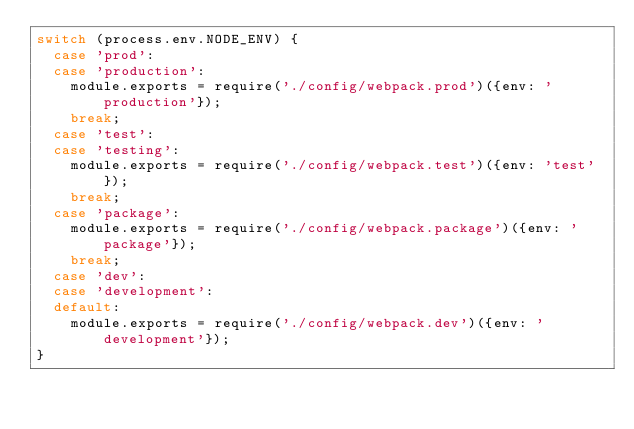<code> <loc_0><loc_0><loc_500><loc_500><_JavaScript_>switch (process.env.NODE_ENV) {
  case 'prod':
  case 'production':
    module.exports = require('./config/webpack.prod')({env: 'production'});
    break;
  case 'test':
  case 'testing':
    module.exports = require('./config/webpack.test')({env: 'test'});
    break;
  case 'package':
    module.exports = require('./config/webpack.package')({env: 'package'});
    break;
  case 'dev':
  case 'development':
  default:
    module.exports = require('./config/webpack.dev')({env: 'development'});
}</code> 